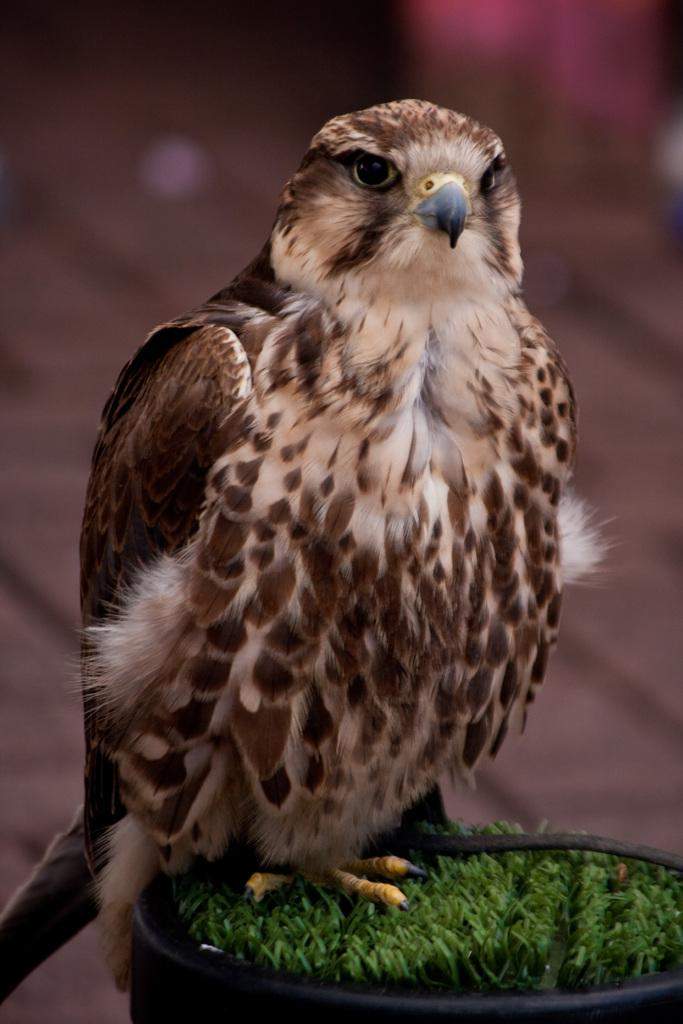What type of animal is in the image? There is a bird in the image. Can you describe the bird's appearance? The bird is white and brown in color. Where is the bird located in the image? The bird is sitting on the grass. What can be observed about the background of the image? The background of the image is blurred. What type of pan is the bird using to cook a loaf in the image? There is no pan or loaf present in the image; it features a bird sitting on the grass. 